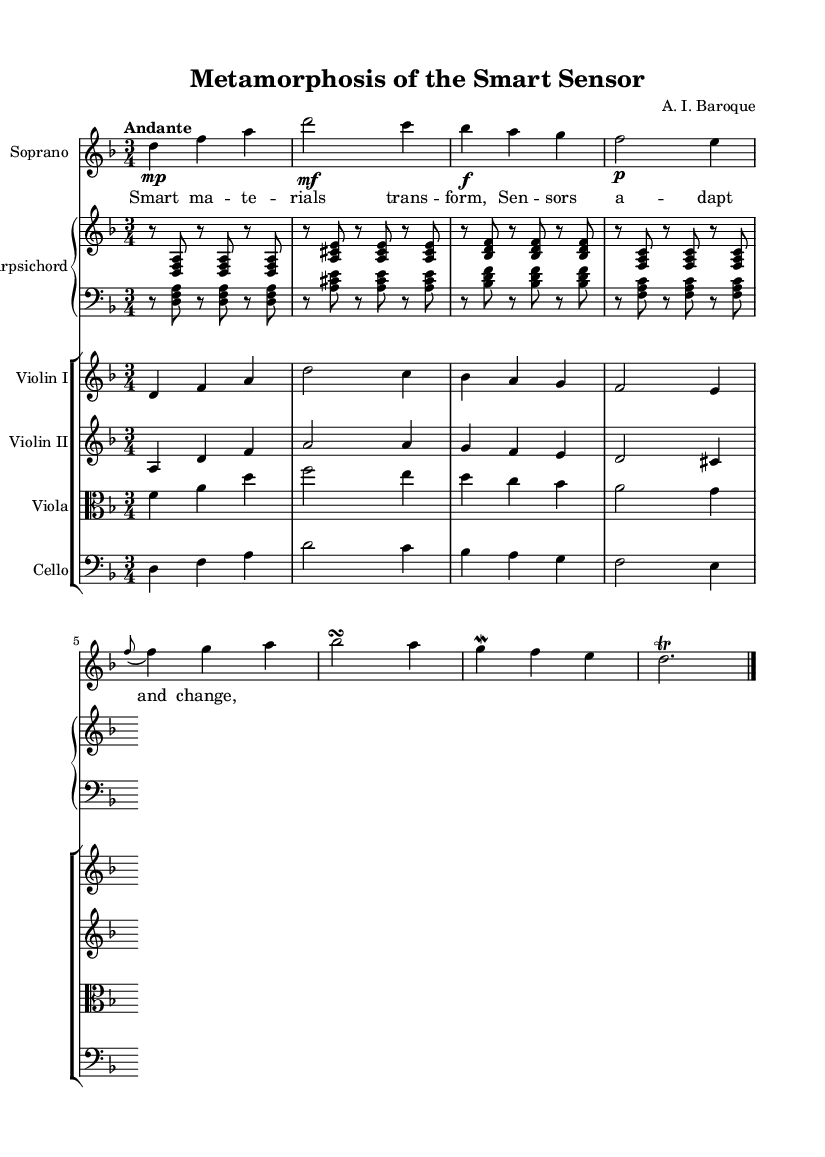What is the key signature of this music? The key signature is two flats, which indicates that the music is in D minor. The presence of these flats can be found at the beginning of the staff.
Answer: D minor What is the time signature of the piece? The time signature is displayed at the beginning of the score and is indicated by the numbers above the staff. It shows a 3 on top of a 4, meaning there are three beats in each measure and each beat is a quarter note.
Answer: 3/4 What is the tempo marking for the piece? The tempo marking is "Andante," which is written above the musical notes and indicates a moderately slow pace. This definition of andante can be understood contextually for Baroque music, signifying a steady, flowing tempo.
Answer: Andante How many instruments are featured in this score? By observing the layout of the score, we can see that there are six parts listed: Soprano, Violin I, Violin II, Viola, Cello, and Harpsichord, thus indicating a total of six instruments.
Answer: Six What type of ornamentation appears in the soprano line? The soprano line features both a trill (d2.) and a mordent (g4 f), which are common ornamentations in Baroque music, enhancing expressiveness in the melody. The appearance of these symbols indicates their function in the musical context.
Answer: Trill and mordent What is the mood conveyed in the lyrics of the aria? The lyrics point to a theme of transformation and adaptation, highlighting the responsive nature of smart materials and their applications, which can be linked to emotional expression often found in operatic arias.
Answer: Transformation 